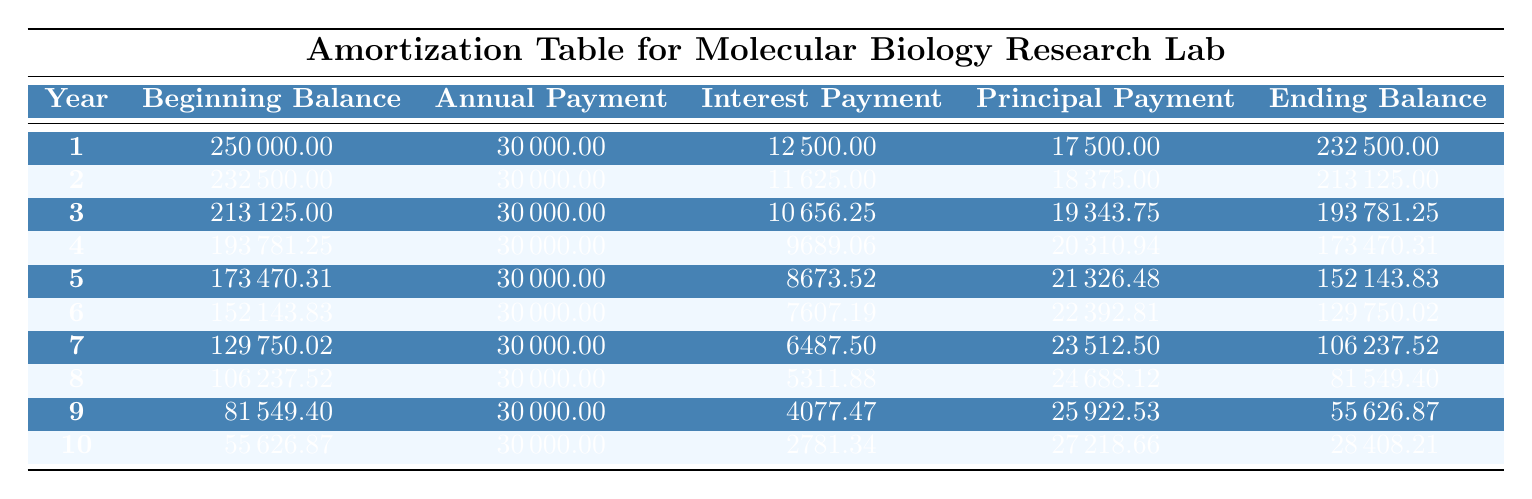What is the total annual payment made in the first year? The table indicates that the annual payment for the first year is listed in the "Annual Payment" column for year 1, which is 30000.00. Thus, the total annual payment made in the first year is 30000.00.
Answer: 30000.00 What is the ending balance after the 5th year? By looking at the "Ending Balance" column for year 5, we can see that the ending balance is reported as 152143.83. This is the balance after all payments and interest adjustments have been made.
Answer: 152143.83 How much principal was paid off in the last year? The table shows that in year 10, the "Principal Payment" is listed as 27218.66. This indicates the amount of the principal paid off during that year.
Answer: 27218.66 Is the total interest paid over the entire period more than 30000? To determine this, we need to sum the "Interest Payment" column from years 1 to 10. The total interest can be calculated as 12500 + 11625 + 10656.25 + 9689.06 + 8673.52 + 7607.19 + 6487.50 + 5311.88 + 4077.47 + 2781.34 = 77607.21. Since 77607.21 is greater than 30000, the statement is true.
Answer: Yes What is the average annual principal payment over the entire period? The total principal paid is calculated by summing up the "Principal Payment" amounts for each year: 17500 + 18375 + 19343.75 + 20310.94 + 21326.48 + 22392.81 + 23512.50 + 24688.12 + 25922.53 + 27218.66 =  233057.79. The average is then calculated by dividing this total by the number of years: 233057.79 / 10 = 23305.779.
Answer: 23305.78 